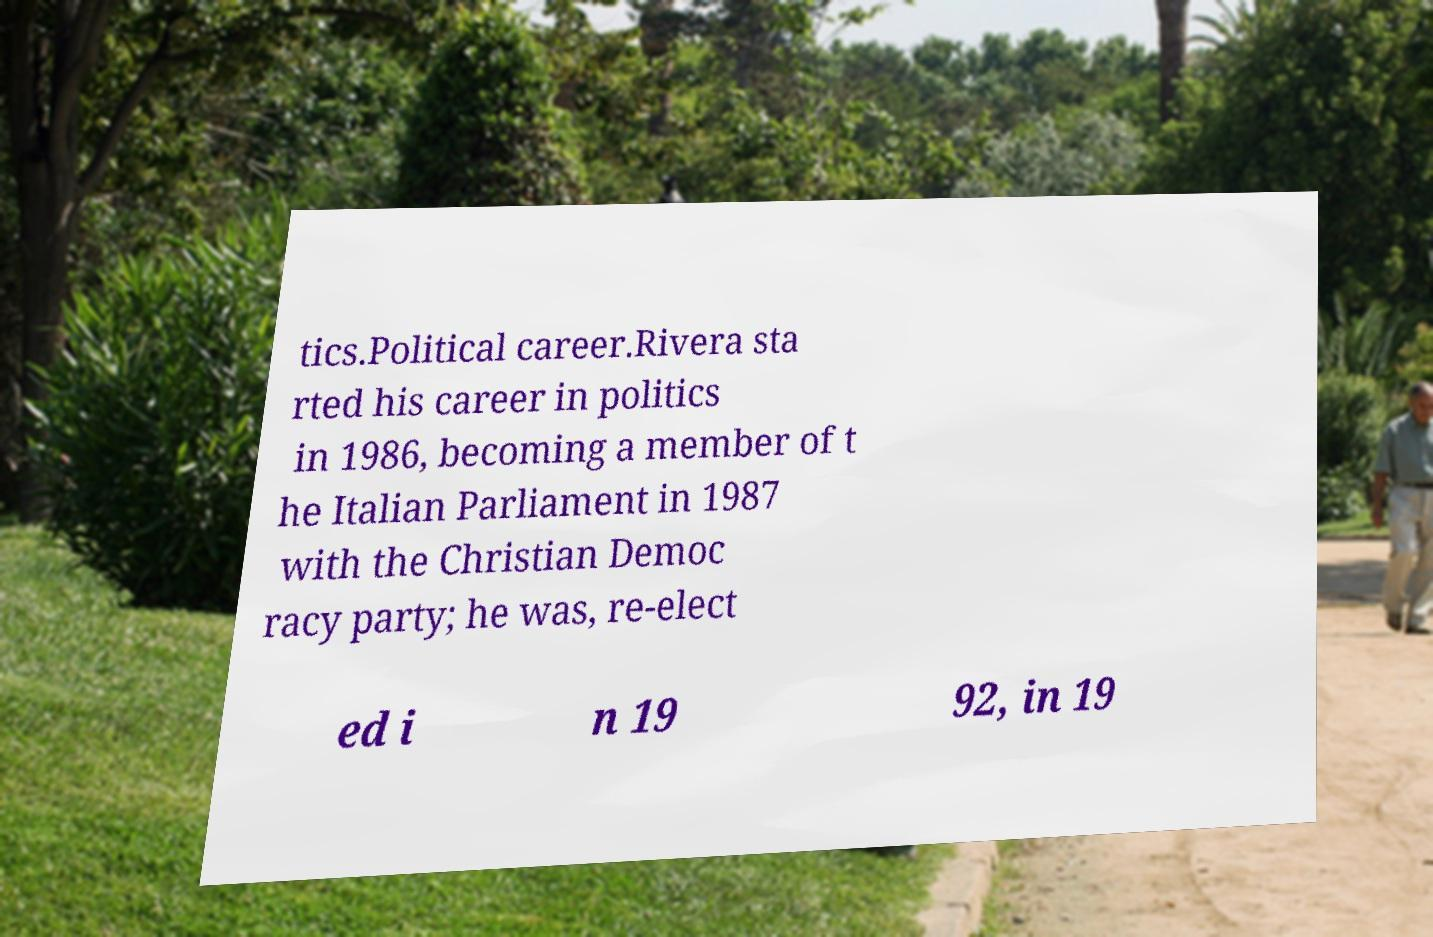For documentation purposes, I need the text within this image transcribed. Could you provide that? tics.Political career.Rivera sta rted his career in politics in 1986, becoming a member of t he Italian Parliament in 1987 with the Christian Democ racy party; he was, re-elect ed i n 19 92, in 19 